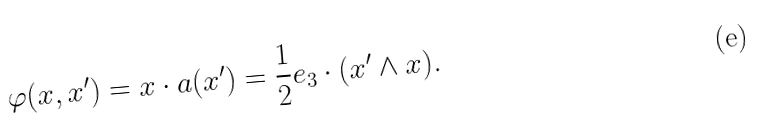Convert formula to latex. <formula><loc_0><loc_0><loc_500><loc_500>\varphi ( { x } , { x ^ { \prime } } ) = { x } \cdot { a } ( { x ^ { \prime } } ) = \frac { 1 } { 2 } { e _ { 3 } } \cdot ( { x ^ { \prime } } \wedge { x } ) .</formula> 